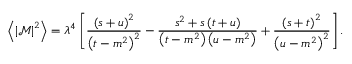Convert formula to latex. <formula><loc_0><loc_0><loc_500><loc_500>\left \langle \left | \mathcal { M } \right | ^ { 2 } \right \rangle = \lambda ^ { 4 } \left [ \frac { \left ( s + u \right ) ^ { 2 } } { \left ( t - m ^ { 2 } \right ) ^ { 2 } } - \frac { s ^ { 2 } + s \left ( t + u \right ) } { \left ( t - m ^ { 2 } \right ) \left ( u - m ^ { 2 } \right ) } + \frac { \left ( s + t \right ) ^ { 2 } } { \left ( u - m ^ { 2 } \right ) ^ { 2 } } \right ] .</formula> 